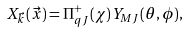<formula> <loc_0><loc_0><loc_500><loc_500>X _ { \vec { k } } ( \vec { x } ) = \Pi _ { q J } ^ { + } ( \chi ) Y _ { M J } ( \theta , \phi ) ,</formula> 